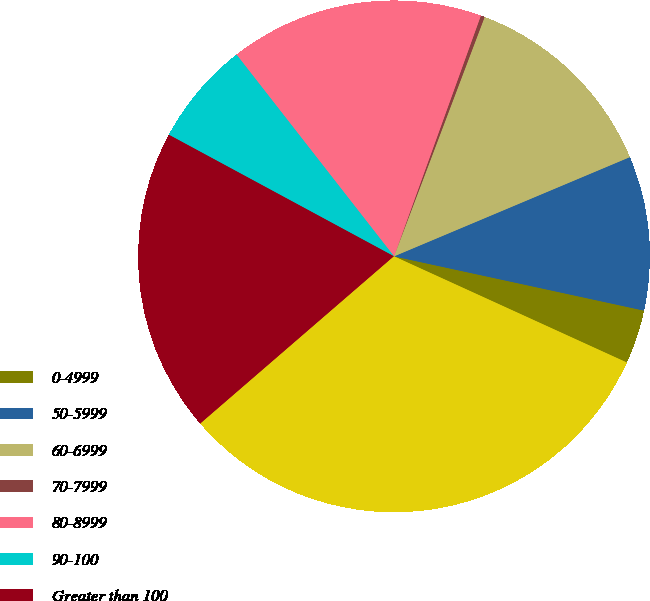Convert chart to OTSL. <chart><loc_0><loc_0><loc_500><loc_500><pie_chart><fcel>0-4999<fcel>50-5999<fcel>60-6999<fcel>70-7999<fcel>80-8999<fcel>90-100<fcel>Greater than 100<fcel>Total commercial and<nl><fcel>3.41%<fcel>9.74%<fcel>12.9%<fcel>0.25%<fcel>16.06%<fcel>6.57%<fcel>19.22%<fcel>31.85%<nl></chart> 